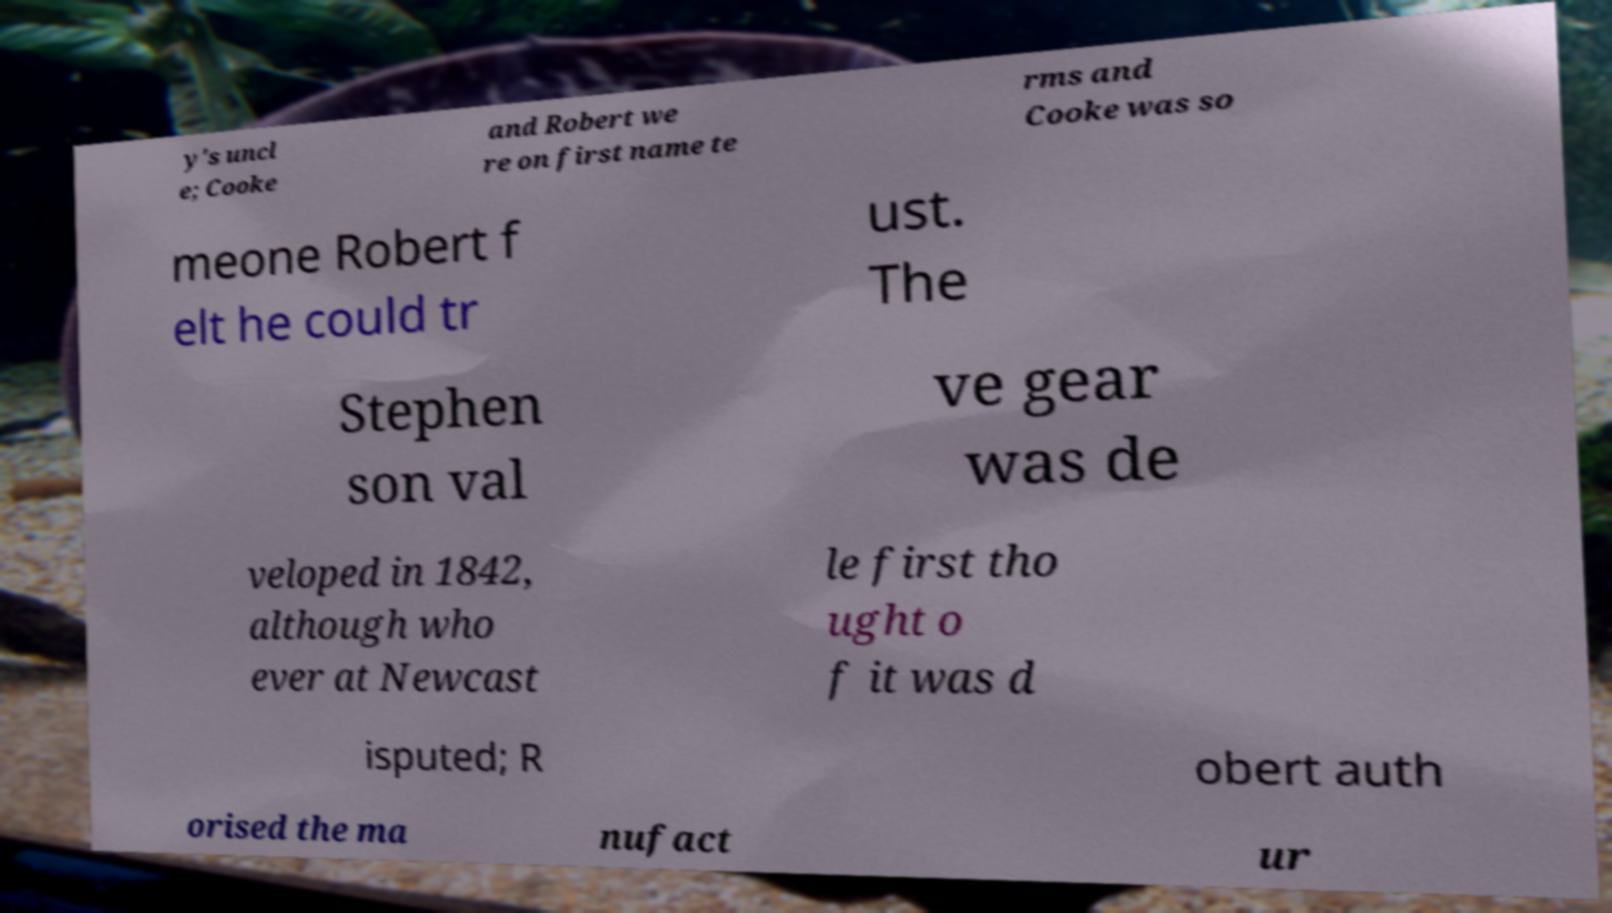For documentation purposes, I need the text within this image transcribed. Could you provide that? y's uncl e; Cooke and Robert we re on first name te rms and Cooke was so meone Robert f elt he could tr ust. The Stephen son val ve gear was de veloped in 1842, although who ever at Newcast le first tho ught o f it was d isputed; R obert auth orised the ma nufact ur 